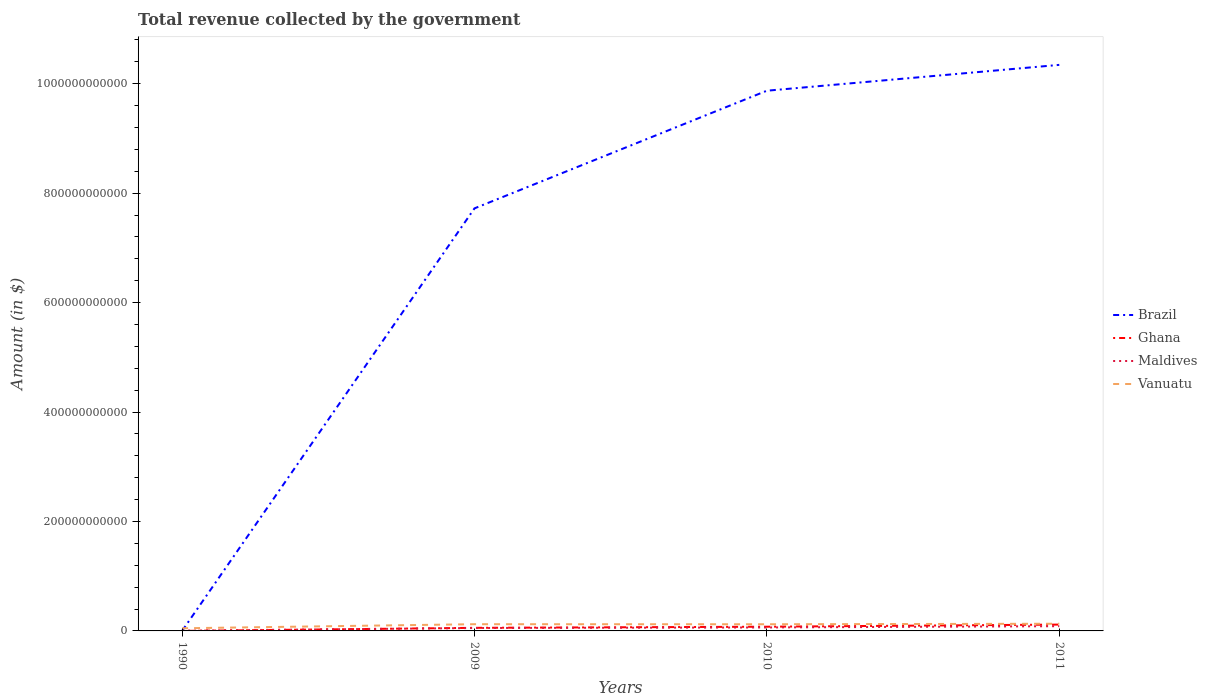How many different coloured lines are there?
Provide a short and direct response. 4. Is the number of lines equal to the number of legend labels?
Your response must be concise. Yes. Across all years, what is the maximum total revenue collected by the government in Brazil?
Give a very brief answer. 2.63e+06. What is the total total revenue collected by the government in Maldives in the graph?
Offer a terse response. -1.04e+09. What is the difference between the highest and the second highest total revenue collected by the government in Brazil?
Give a very brief answer. 1.03e+12. What is the difference between two consecutive major ticks on the Y-axis?
Ensure brevity in your answer.  2.00e+11. Are the values on the major ticks of Y-axis written in scientific E-notation?
Provide a succinct answer. No. Does the graph contain any zero values?
Provide a succinct answer. No. Where does the legend appear in the graph?
Give a very brief answer. Center right. How many legend labels are there?
Make the answer very short. 4. What is the title of the graph?
Offer a terse response. Total revenue collected by the government. Does "Middle income" appear as one of the legend labels in the graph?
Ensure brevity in your answer.  No. What is the label or title of the X-axis?
Your response must be concise. Years. What is the label or title of the Y-axis?
Your answer should be very brief. Amount (in $). What is the Amount (in $) of Brazil in 1990?
Your response must be concise. 2.63e+06. What is the Amount (in $) in Ghana in 1990?
Offer a terse response. 2.40e+07. What is the Amount (in $) in Maldives in 1990?
Provide a succinct answer. 4.55e+08. What is the Amount (in $) in Vanuatu in 1990?
Provide a succinct answer. 4.85e+09. What is the Amount (in $) in Brazil in 2009?
Offer a terse response. 7.72e+11. What is the Amount (in $) of Ghana in 2009?
Your answer should be very brief. 5.64e+09. What is the Amount (in $) of Maldives in 2009?
Give a very brief answer. 5.30e+09. What is the Amount (in $) of Vanuatu in 2009?
Provide a short and direct response. 1.23e+1. What is the Amount (in $) in Brazil in 2010?
Offer a very short reply. 9.87e+11. What is the Amount (in $) in Ghana in 2010?
Offer a terse response. 7.69e+09. What is the Amount (in $) in Maldives in 2010?
Offer a terse response. 6.34e+09. What is the Amount (in $) of Vanuatu in 2010?
Provide a succinct answer. 1.22e+1. What is the Amount (in $) of Brazil in 2011?
Provide a succinct answer. 1.03e+12. What is the Amount (in $) of Ghana in 2011?
Offer a terse response. 1.16e+1. What is the Amount (in $) of Maldives in 2011?
Ensure brevity in your answer.  8.64e+09. What is the Amount (in $) of Vanuatu in 2011?
Ensure brevity in your answer.  1.31e+1. Across all years, what is the maximum Amount (in $) of Brazil?
Your answer should be compact. 1.03e+12. Across all years, what is the maximum Amount (in $) in Ghana?
Make the answer very short. 1.16e+1. Across all years, what is the maximum Amount (in $) in Maldives?
Make the answer very short. 8.64e+09. Across all years, what is the maximum Amount (in $) of Vanuatu?
Your answer should be very brief. 1.31e+1. Across all years, what is the minimum Amount (in $) of Brazil?
Make the answer very short. 2.63e+06. Across all years, what is the minimum Amount (in $) of Ghana?
Your answer should be compact. 2.40e+07. Across all years, what is the minimum Amount (in $) of Maldives?
Provide a short and direct response. 4.55e+08. Across all years, what is the minimum Amount (in $) in Vanuatu?
Ensure brevity in your answer.  4.85e+09. What is the total Amount (in $) of Brazil in the graph?
Offer a terse response. 2.79e+12. What is the total Amount (in $) in Ghana in the graph?
Give a very brief answer. 2.49e+1. What is the total Amount (in $) of Maldives in the graph?
Provide a short and direct response. 2.07e+1. What is the total Amount (in $) of Vanuatu in the graph?
Make the answer very short. 4.25e+1. What is the difference between the Amount (in $) of Brazil in 1990 and that in 2009?
Ensure brevity in your answer.  -7.72e+11. What is the difference between the Amount (in $) in Ghana in 1990 and that in 2009?
Make the answer very short. -5.62e+09. What is the difference between the Amount (in $) in Maldives in 1990 and that in 2009?
Offer a terse response. -4.84e+09. What is the difference between the Amount (in $) of Vanuatu in 1990 and that in 2009?
Make the answer very short. -7.44e+09. What is the difference between the Amount (in $) of Brazil in 1990 and that in 2010?
Keep it short and to the point. -9.87e+11. What is the difference between the Amount (in $) of Ghana in 1990 and that in 2010?
Offer a terse response. -7.66e+09. What is the difference between the Amount (in $) of Maldives in 1990 and that in 2010?
Offer a terse response. -5.89e+09. What is the difference between the Amount (in $) in Vanuatu in 1990 and that in 2010?
Offer a very short reply. -7.34e+09. What is the difference between the Amount (in $) of Brazil in 1990 and that in 2011?
Keep it short and to the point. -1.03e+12. What is the difference between the Amount (in $) in Ghana in 1990 and that in 2011?
Keep it short and to the point. -1.16e+1. What is the difference between the Amount (in $) in Maldives in 1990 and that in 2011?
Provide a succinct answer. -8.18e+09. What is the difference between the Amount (in $) of Vanuatu in 1990 and that in 2011?
Your response must be concise. -8.29e+09. What is the difference between the Amount (in $) in Brazil in 2009 and that in 2010?
Your answer should be very brief. -2.15e+11. What is the difference between the Amount (in $) of Ghana in 2009 and that in 2010?
Provide a short and direct response. -2.04e+09. What is the difference between the Amount (in $) of Maldives in 2009 and that in 2010?
Your answer should be very brief. -1.04e+09. What is the difference between the Amount (in $) in Vanuatu in 2009 and that in 2010?
Your answer should be very brief. 1.04e+08. What is the difference between the Amount (in $) in Brazil in 2009 and that in 2011?
Ensure brevity in your answer.  -2.62e+11. What is the difference between the Amount (in $) of Ghana in 2009 and that in 2011?
Your answer should be very brief. -5.94e+09. What is the difference between the Amount (in $) in Maldives in 2009 and that in 2011?
Offer a very short reply. -3.34e+09. What is the difference between the Amount (in $) in Vanuatu in 2009 and that in 2011?
Your response must be concise. -8.41e+08. What is the difference between the Amount (in $) in Brazil in 2010 and that in 2011?
Offer a very short reply. -4.72e+1. What is the difference between the Amount (in $) in Ghana in 2010 and that in 2011?
Provide a short and direct response. -3.90e+09. What is the difference between the Amount (in $) of Maldives in 2010 and that in 2011?
Your response must be concise. -2.29e+09. What is the difference between the Amount (in $) of Vanuatu in 2010 and that in 2011?
Provide a short and direct response. -9.45e+08. What is the difference between the Amount (in $) of Brazil in 1990 and the Amount (in $) of Ghana in 2009?
Your response must be concise. -5.64e+09. What is the difference between the Amount (in $) of Brazil in 1990 and the Amount (in $) of Maldives in 2009?
Keep it short and to the point. -5.30e+09. What is the difference between the Amount (in $) in Brazil in 1990 and the Amount (in $) in Vanuatu in 2009?
Your answer should be very brief. -1.23e+1. What is the difference between the Amount (in $) in Ghana in 1990 and the Amount (in $) in Maldives in 2009?
Offer a terse response. -5.28e+09. What is the difference between the Amount (in $) in Ghana in 1990 and the Amount (in $) in Vanuatu in 2009?
Ensure brevity in your answer.  -1.23e+1. What is the difference between the Amount (in $) in Maldives in 1990 and the Amount (in $) in Vanuatu in 2009?
Your response must be concise. -1.18e+1. What is the difference between the Amount (in $) of Brazil in 1990 and the Amount (in $) of Ghana in 2010?
Offer a terse response. -7.68e+09. What is the difference between the Amount (in $) in Brazil in 1990 and the Amount (in $) in Maldives in 2010?
Your answer should be very brief. -6.34e+09. What is the difference between the Amount (in $) in Brazil in 1990 and the Amount (in $) in Vanuatu in 2010?
Ensure brevity in your answer.  -1.22e+1. What is the difference between the Amount (in $) in Ghana in 1990 and the Amount (in $) in Maldives in 2010?
Give a very brief answer. -6.32e+09. What is the difference between the Amount (in $) of Ghana in 1990 and the Amount (in $) of Vanuatu in 2010?
Give a very brief answer. -1.22e+1. What is the difference between the Amount (in $) of Maldives in 1990 and the Amount (in $) of Vanuatu in 2010?
Make the answer very short. -1.17e+1. What is the difference between the Amount (in $) of Brazil in 1990 and the Amount (in $) of Ghana in 2011?
Your answer should be compact. -1.16e+1. What is the difference between the Amount (in $) of Brazil in 1990 and the Amount (in $) of Maldives in 2011?
Your answer should be very brief. -8.64e+09. What is the difference between the Amount (in $) of Brazil in 1990 and the Amount (in $) of Vanuatu in 2011?
Your response must be concise. -1.31e+1. What is the difference between the Amount (in $) of Ghana in 1990 and the Amount (in $) of Maldives in 2011?
Keep it short and to the point. -8.61e+09. What is the difference between the Amount (in $) of Ghana in 1990 and the Amount (in $) of Vanuatu in 2011?
Provide a short and direct response. -1.31e+1. What is the difference between the Amount (in $) in Maldives in 1990 and the Amount (in $) in Vanuatu in 2011?
Provide a succinct answer. -1.27e+1. What is the difference between the Amount (in $) in Brazil in 2009 and the Amount (in $) in Ghana in 2010?
Keep it short and to the point. 7.64e+11. What is the difference between the Amount (in $) in Brazil in 2009 and the Amount (in $) in Maldives in 2010?
Provide a succinct answer. 7.66e+11. What is the difference between the Amount (in $) in Brazil in 2009 and the Amount (in $) in Vanuatu in 2010?
Provide a short and direct response. 7.60e+11. What is the difference between the Amount (in $) of Ghana in 2009 and the Amount (in $) of Maldives in 2010?
Provide a succinct answer. -7.00e+08. What is the difference between the Amount (in $) in Ghana in 2009 and the Amount (in $) in Vanuatu in 2010?
Make the answer very short. -6.54e+09. What is the difference between the Amount (in $) of Maldives in 2009 and the Amount (in $) of Vanuatu in 2010?
Your response must be concise. -6.89e+09. What is the difference between the Amount (in $) in Brazil in 2009 and the Amount (in $) in Ghana in 2011?
Ensure brevity in your answer.  7.61e+11. What is the difference between the Amount (in $) of Brazil in 2009 and the Amount (in $) of Maldives in 2011?
Keep it short and to the point. 7.64e+11. What is the difference between the Amount (in $) in Brazil in 2009 and the Amount (in $) in Vanuatu in 2011?
Offer a very short reply. 7.59e+11. What is the difference between the Amount (in $) in Ghana in 2009 and the Amount (in $) in Maldives in 2011?
Ensure brevity in your answer.  -2.99e+09. What is the difference between the Amount (in $) in Ghana in 2009 and the Amount (in $) in Vanuatu in 2011?
Your response must be concise. -7.49e+09. What is the difference between the Amount (in $) in Maldives in 2009 and the Amount (in $) in Vanuatu in 2011?
Keep it short and to the point. -7.83e+09. What is the difference between the Amount (in $) in Brazil in 2010 and the Amount (in $) in Ghana in 2011?
Your answer should be compact. 9.76e+11. What is the difference between the Amount (in $) in Brazil in 2010 and the Amount (in $) in Maldives in 2011?
Keep it short and to the point. 9.79e+11. What is the difference between the Amount (in $) in Brazil in 2010 and the Amount (in $) in Vanuatu in 2011?
Provide a succinct answer. 9.74e+11. What is the difference between the Amount (in $) in Ghana in 2010 and the Amount (in $) in Maldives in 2011?
Your answer should be very brief. -9.53e+08. What is the difference between the Amount (in $) of Ghana in 2010 and the Amount (in $) of Vanuatu in 2011?
Provide a succinct answer. -5.45e+09. What is the difference between the Amount (in $) of Maldives in 2010 and the Amount (in $) of Vanuatu in 2011?
Offer a very short reply. -6.79e+09. What is the average Amount (in $) in Brazil per year?
Provide a short and direct response. 6.98e+11. What is the average Amount (in $) in Ghana per year?
Provide a succinct answer. 6.23e+09. What is the average Amount (in $) in Maldives per year?
Provide a short and direct response. 5.18e+09. What is the average Amount (in $) in Vanuatu per year?
Offer a terse response. 1.06e+1. In the year 1990, what is the difference between the Amount (in $) in Brazil and Amount (in $) in Ghana?
Offer a terse response. -2.13e+07. In the year 1990, what is the difference between the Amount (in $) of Brazil and Amount (in $) of Maldives?
Give a very brief answer. -4.52e+08. In the year 1990, what is the difference between the Amount (in $) of Brazil and Amount (in $) of Vanuatu?
Your answer should be compact. -4.84e+09. In the year 1990, what is the difference between the Amount (in $) of Ghana and Amount (in $) of Maldives?
Your answer should be compact. -4.31e+08. In the year 1990, what is the difference between the Amount (in $) in Ghana and Amount (in $) in Vanuatu?
Give a very brief answer. -4.82e+09. In the year 1990, what is the difference between the Amount (in $) of Maldives and Amount (in $) of Vanuatu?
Offer a very short reply. -4.39e+09. In the year 2009, what is the difference between the Amount (in $) of Brazil and Amount (in $) of Ghana?
Provide a short and direct response. 7.67e+11. In the year 2009, what is the difference between the Amount (in $) in Brazil and Amount (in $) in Maldives?
Your response must be concise. 7.67e+11. In the year 2009, what is the difference between the Amount (in $) of Brazil and Amount (in $) of Vanuatu?
Your response must be concise. 7.60e+11. In the year 2009, what is the difference between the Amount (in $) in Ghana and Amount (in $) in Maldives?
Provide a short and direct response. 3.43e+08. In the year 2009, what is the difference between the Amount (in $) in Ghana and Amount (in $) in Vanuatu?
Offer a terse response. -6.65e+09. In the year 2009, what is the difference between the Amount (in $) of Maldives and Amount (in $) of Vanuatu?
Keep it short and to the point. -6.99e+09. In the year 2010, what is the difference between the Amount (in $) of Brazil and Amount (in $) of Ghana?
Your answer should be very brief. 9.79e+11. In the year 2010, what is the difference between the Amount (in $) in Brazil and Amount (in $) in Maldives?
Offer a terse response. 9.81e+11. In the year 2010, what is the difference between the Amount (in $) in Brazil and Amount (in $) in Vanuatu?
Your response must be concise. 9.75e+11. In the year 2010, what is the difference between the Amount (in $) of Ghana and Amount (in $) of Maldives?
Give a very brief answer. 1.34e+09. In the year 2010, what is the difference between the Amount (in $) of Ghana and Amount (in $) of Vanuatu?
Provide a short and direct response. -4.50e+09. In the year 2010, what is the difference between the Amount (in $) in Maldives and Amount (in $) in Vanuatu?
Provide a succinct answer. -5.84e+09. In the year 2011, what is the difference between the Amount (in $) in Brazil and Amount (in $) in Ghana?
Your answer should be compact. 1.02e+12. In the year 2011, what is the difference between the Amount (in $) in Brazil and Amount (in $) in Maldives?
Ensure brevity in your answer.  1.03e+12. In the year 2011, what is the difference between the Amount (in $) of Brazil and Amount (in $) of Vanuatu?
Your answer should be very brief. 1.02e+12. In the year 2011, what is the difference between the Amount (in $) of Ghana and Amount (in $) of Maldives?
Your response must be concise. 2.95e+09. In the year 2011, what is the difference between the Amount (in $) of Ghana and Amount (in $) of Vanuatu?
Offer a very short reply. -1.54e+09. In the year 2011, what is the difference between the Amount (in $) in Maldives and Amount (in $) in Vanuatu?
Offer a very short reply. -4.49e+09. What is the ratio of the Amount (in $) in Brazil in 1990 to that in 2009?
Provide a succinct answer. 0. What is the ratio of the Amount (in $) of Ghana in 1990 to that in 2009?
Your response must be concise. 0. What is the ratio of the Amount (in $) in Maldives in 1990 to that in 2009?
Ensure brevity in your answer.  0.09. What is the ratio of the Amount (in $) in Vanuatu in 1990 to that in 2009?
Make the answer very short. 0.39. What is the ratio of the Amount (in $) in Ghana in 1990 to that in 2010?
Give a very brief answer. 0. What is the ratio of the Amount (in $) of Maldives in 1990 to that in 2010?
Ensure brevity in your answer.  0.07. What is the ratio of the Amount (in $) in Vanuatu in 1990 to that in 2010?
Your answer should be very brief. 0.4. What is the ratio of the Amount (in $) of Brazil in 1990 to that in 2011?
Give a very brief answer. 0. What is the ratio of the Amount (in $) of Ghana in 1990 to that in 2011?
Provide a succinct answer. 0. What is the ratio of the Amount (in $) in Maldives in 1990 to that in 2011?
Provide a succinct answer. 0.05. What is the ratio of the Amount (in $) of Vanuatu in 1990 to that in 2011?
Provide a short and direct response. 0.37. What is the ratio of the Amount (in $) of Brazil in 2009 to that in 2010?
Ensure brevity in your answer.  0.78. What is the ratio of the Amount (in $) in Ghana in 2009 to that in 2010?
Offer a very short reply. 0.73. What is the ratio of the Amount (in $) of Maldives in 2009 to that in 2010?
Provide a short and direct response. 0.84. What is the ratio of the Amount (in $) in Vanuatu in 2009 to that in 2010?
Provide a succinct answer. 1.01. What is the ratio of the Amount (in $) in Brazil in 2009 to that in 2011?
Offer a very short reply. 0.75. What is the ratio of the Amount (in $) in Ghana in 2009 to that in 2011?
Your answer should be compact. 0.49. What is the ratio of the Amount (in $) of Maldives in 2009 to that in 2011?
Make the answer very short. 0.61. What is the ratio of the Amount (in $) in Vanuatu in 2009 to that in 2011?
Offer a terse response. 0.94. What is the ratio of the Amount (in $) of Brazil in 2010 to that in 2011?
Make the answer very short. 0.95. What is the ratio of the Amount (in $) of Ghana in 2010 to that in 2011?
Offer a very short reply. 0.66. What is the ratio of the Amount (in $) of Maldives in 2010 to that in 2011?
Offer a terse response. 0.73. What is the ratio of the Amount (in $) in Vanuatu in 2010 to that in 2011?
Provide a succinct answer. 0.93. What is the difference between the highest and the second highest Amount (in $) in Brazil?
Ensure brevity in your answer.  4.72e+1. What is the difference between the highest and the second highest Amount (in $) of Ghana?
Ensure brevity in your answer.  3.90e+09. What is the difference between the highest and the second highest Amount (in $) in Maldives?
Your answer should be very brief. 2.29e+09. What is the difference between the highest and the second highest Amount (in $) of Vanuatu?
Offer a very short reply. 8.41e+08. What is the difference between the highest and the lowest Amount (in $) of Brazil?
Your response must be concise. 1.03e+12. What is the difference between the highest and the lowest Amount (in $) of Ghana?
Ensure brevity in your answer.  1.16e+1. What is the difference between the highest and the lowest Amount (in $) of Maldives?
Your answer should be very brief. 8.18e+09. What is the difference between the highest and the lowest Amount (in $) in Vanuatu?
Provide a succinct answer. 8.29e+09. 